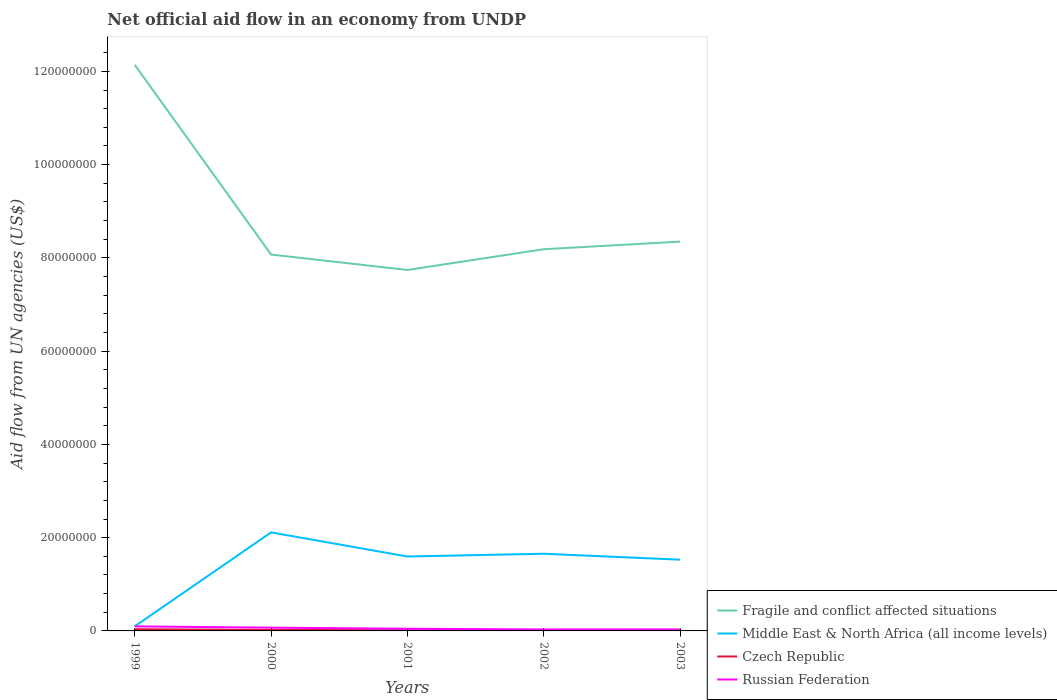How many different coloured lines are there?
Offer a very short reply. 4. Across all years, what is the maximum net official aid flow in Middle East & North Africa (all income levels)?
Your answer should be compact. 9.90e+05. In which year was the net official aid flow in Russian Federation maximum?
Give a very brief answer. 2002. What is the total net official aid flow in Fragile and conflict affected situations in the graph?
Your answer should be compact. 3.79e+07. Is the net official aid flow in Russian Federation strictly greater than the net official aid flow in Fragile and conflict affected situations over the years?
Give a very brief answer. Yes. How many lines are there?
Your response must be concise. 4. What is the difference between two consecutive major ticks on the Y-axis?
Provide a succinct answer. 2.00e+07. Where does the legend appear in the graph?
Offer a very short reply. Bottom right. How many legend labels are there?
Offer a very short reply. 4. How are the legend labels stacked?
Provide a short and direct response. Vertical. What is the title of the graph?
Provide a short and direct response. Net official aid flow in an economy from UNDP. Does "United Kingdom" appear as one of the legend labels in the graph?
Ensure brevity in your answer.  No. What is the label or title of the Y-axis?
Your response must be concise. Aid flow from UN agencies (US$). What is the Aid flow from UN agencies (US$) of Fragile and conflict affected situations in 1999?
Provide a succinct answer. 1.21e+08. What is the Aid flow from UN agencies (US$) of Middle East & North Africa (all income levels) in 1999?
Ensure brevity in your answer.  9.90e+05. What is the Aid flow from UN agencies (US$) in Czech Republic in 1999?
Your response must be concise. 3.70e+05. What is the Aid flow from UN agencies (US$) of Russian Federation in 1999?
Provide a short and direct response. 9.70e+05. What is the Aid flow from UN agencies (US$) in Fragile and conflict affected situations in 2000?
Your answer should be very brief. 8.07e+07. What is the Aid flow from UN agencies (US$) in Middle East & North Africa (all income levels) in 2000?
Provide a short and direct response. 2.11e+07. What is the Aid flow from UN agencies (US$) in Fragile and conflict affected situations in 2001?
Provide a succinct answer. 7.74e+07. What is the Aid flow from UN agencies (US$) of Middle East & North Africa (all income levels) in 2001?
Provide a short and direct response. 1.60e+07. What is the Aid flow from UN agencies (US$) of Czech Republic in 2001?
Offer a very short reply. 1.40e+05. What is the Aid flow from UN agencies (US$) in Fragile and conflict affected situations in 2002?
Keep it short and to the point. 8.19e+07. What is the Aid flow from UN agencies (US$) in Middle East & North Africa (all income levels) in 2002?
Your response must be concise. 1.66e+07. What is the Aid flow from UN agencies (US$) in Czech Republic in 2002?
Ensure brevity in your answer.  8.00e+04. What is the Aid flow from UN agencies (US$) in Fragile and conflict affected situations in 2003?
Your answer should be very brief. 8.35e+07. What is the Aid flow from UN agencies (US$) in Middle East & North Africa (all income levels) in 2003?
Offer a terse response. 1.53e+07. What is the Aid flow from UN agencies (US$) of Russian Federation in 2003?
Give a very brief answer. 3.20e+05. Across all years, what is the maximum Aid flow from UN agencies (US$) of Fragile and conflict affected situations?
Offer a very short reply. 1.21e+08. Across all years, what is the maximum Aid flow from UN agencies (US$) in Middle East & North Africa (all income levels)?
Keep it short and to the point. 2.11e+07. Across all years, what is the maximum Aid flow from UN agencies (US$) in Czech Republic?
Offer a terse response. 3.70e+05. Across all years, what is the maximum Aid flow from UN agencies (US$) of Russian Federation?
Give a very brief answer. 9.70e+05. Across all years, what is the minimum Aid flow from UN agencies (US$) in Fragile and conflict affected situations?
Offer a very short reply. 7.74e+07. Across all years, what is the minimum Aid flow from UN agencies (US$) of Middle East & North Africa (all income levels)?
Offer a terse response. 9.90e+05. Across all years, what is the minimum Aid flow from UN agencies (US$) of Russian Federation?
Offer a terse response. 3.10e+05. What is the total Aid flow from UN agencies (US$) of Fragile and conflict affected situations in the graph?
Your response must be concise. 4.45e+08. What is the total Aid flow from UN agencies (US$) in Middle East & North Africa (all income levels) in the graph?
Your answer should be compact. 6.99e+07. What is the total Aid flow from UN agencies (US$) of Czech Republic in the graph?
Offer a terse response. 9.10e+05. What is the total Aid flow from UN agencies (US$) of Russian Federation in the graph?
Your answer should be very brief. 2.77e+06. What is the difference between the Aid flow from UN agencies (US$) in Fragile and conflict affected situations in 1999 and that in 2000?
Provide a succinct answer. 4.07e+07. What is the difference between the Aid flow from UN agencies (US$) of Middle East & North Africa (all income levels) in 1999 and that in 2000?
Your answer should be very brief. -2.01e+07. What is the difference between the Aid flow from UN agencies (US$) of Fragile and conflict affected situations in 1999 and that in 2001?
Your answer should be very brief. 4.40e+07. What is the difference between the Aid flow from UN agencies (US$) of Middle East & North Africa (all income levels) in 1999 and that in 2001?
Your answer should be compact. -1.50e+07. What is the difference between the Aid flow from UN agencies (US$) in Russian Federation in 1999 and that in 2001?
Your answer should be compact. 5.00e+05. What is the difference between the Aid flow from UN agencies (US$) of Fragile and conflict affected situations in 1999 and that in 2002?
Offer a terse response. 3.95e+07. What is the difference between the Aid flow from UN agencies (US$) of Middle East & North Africa (all income levels) in 1999 and that in 2002?
Give a very brief answer. -1.56e+07. What is the difference between the Aid flow from UN agencies (US$) of Fragile and conflict affected situations in 1999 and that in 2003?
Ensure brevity in your answer.  3.79e+07. What is the difference between the Aid flow from UN agencies (US$) in Middle East & North Africa (all income levels) in 1999 and that in 2003?
Provide a short and direct response. -1.43e+07. What is the difference between the Aid flow from UN agencies (US$) in Czech Republic in 1999 and that in 2003?
Ensure brevity in your answer.  2.70e+05. What is the difference between the Aid flow from UN agencies (US$) in Russian Federation in 1999 and that in 2003?
Your answer should be compact. 6.50e+05. What is the difference between the Aid flow from UN agencies (US$) in Fragile and conflict affected situations in 2000 and that in 2001?
Provide a succinct answer. 3.31e+06. What is the difference between the Aid flow from UN agencies (US$) in Middle East & North Africa (all income levels) in 2000 and that in 2001?
Offer a very short reply. 5.17e+06. What is the difference between the Aid flow from UN agencies (US$) of Russian Federation in 2000 and that in 2001?
Make the answer very short. 2.30e+05. What is the difference between the Aid flow from UN agencies (US$) in Fragile and conflict affected situations in 2000 and that in 2002?
Provide a short and direct response. -1.14e+06. What is the difference between the Aid flow from UN agencies (US$) in Middle East & North Africa (all income levels) in 2000 and that in 2002?
Your answer should be very brief. 4.58e+06. What is the difference between the Aid flow from UN agencies (US$) in Fragile and conflict affected situations in 2000 and that in 2003?
Your answer should be very brief. -2.77e+06. What is the difference between the Aid flow from UN agencies (US$) in Middle East & North Africa (all income levels) in 2000 and that in 2003?
Offer a terse response. 5.85e+06. What is the difference between the Aid flow from UN agencies (US$) of Czech Republic in 2000 and that in 2003?
Your answer should be very brief. 1.20e+05. What is the difference between the Aid flow from UN agencies (US$) in Fragile and conflict affected situations in 2001 and that in 2002?
Offer a terse response. -4.45e+06. What is the difference between the Aid flow from UN agencies (US$) in Middle East & North Africa (all income levels) in 2001 and that in 2002?
Provide a short and direct response. -5.90e+05. What is the difference between the Aid flow from UN agencies (US$) in Czech Republic in 2001 and that in 2002?
Ensure brevity in your answer.  6.00e+04. What is the difference between the Aid flow from UN agencies (US$) in Russian Federation in 2001 and that in 2002?
Offer a terse response. 1.60e+05. What is the difference between the Aid flow from UN agencies (US$) of Fragile and conflict affected situations in 2001 and that in 2003?
Your response must be concise. -6.08e+06. What is the difference between the Aid flow from UN agencies (US$) of Middle East & North Africa (all income levels) in 2001 and that in 2003?
Provide a succinct answer. 6.80e+05. What is the difference between the Aid flow from UN agencies (US$) of Russian Federation in 2001 and that in 2003?
Give a very brief answer. 1.50e+05. What is the difference between the Aid flow from UN agencies (US$) of Fragile and conflict affected situations in 2002 and that in 2003?
Provide a short and direct response. -1.63e+06. What is the difference between the Aid flow from UN agencies (US$) in Middle East & North Africa (all income levels) in 2002 and that in 2003?
Ensure brevity in your answer.  1.27e+06. What is the difference between the Aid flow from UN agencies (US$) in Czech Republic in 2002 and that in 2003?
Your answer should be compact. -2.00e+04. What is the difference between the Aid flow from UN agencies (US$) in Russian Federation in 2002 and that in 2003?
Offer a very short reply. -10000. What is the difference between the Aid flow from UN agencies (US$) of Fragile and conflict affected situations in 1999 and the Aid flow from UN agencies (US$) of Middle East & North Africa (all income levels) in 2000?
Offer a very short reply. 1.00e+08. What is the difference between the Aid flow from UN agencies (US$) of Fragile and conflict affected situations in 1999 and the Aid flow from UN agencies (US$) of Czech Republic in 2000?
Offer a very short reply. 1.21e+08. What is the difference between the Aid flow from UN agencies (US$) in Fragile and conflict affected situations in 1999 and the Aid flow from UN agencies (US$) in Russian Federation in 2000?
Your answer should be very brief. 1.21e+08. What is the difference between the Aid flow from UN agencies (US$) of Middle East & North Africa (all income levels) in 1999 and the Aid flow from UN agencies (US$) of Czech Republic in 2000?
Provide a short and direct response. 7.70e+05. What is the difference between the Aid flow from UN agencies (US$) in Middle East & North Africa (all income levels) in 1999 and the Aid flow from UN agencies (US$) in Russian Federation in 2000?
Provide a succinct answer. 2.90e+05. What is the difference between the Aid flow from UN agencies (US$) of Czech Republic in 1999 and the Aid flow from UN agencies (US$) of Russian Federation in 2000?
Offer a terse response. -3.30e+05. What is the difference between the Aid flow from UN agencies (US$) in Fragile and conflict affected situations in 1999 and the Aid flow from UN agencies (US$) in Middle East & North Africa (all income levels) in 2001?
Give a very brief answer. 1.05e+08. What is the difference between the Aid flow from UN agencies (US$) of Fragile and conflict affected situations in 1999 and the Aid flow from UN agencies (US$) of Czech Republic in 2001?
Make the answer very short. 1.21e+08. What is the difference between the Aid flow from UN agencies (US$) of Fragile and conflict affected situations in 1999 and the Aid flow from UN agencies (US$) of Russian Federation in 2001?
Offer a terse response. 1.21e+08. What is the difference between the Aid flow from UN agencies (US$) in Middle East & North Africa (all income levels) in 1999 and the Aid flow from UN agencies (US$) in Czech Republic in 2001?
Offer a terse response. 8.50e+05. What is the difference between the Aid flow from UN agencies (US$) in Middle East & North Africa (all income levels) in 1999 and the Aid flow from UN agencies (US$) in Russian Federation in 2001?
Provide a succinct answer. 5.20e+05. What is the difference between the Aid flow from UN agencies (US$) of Czech Republic in 1999 and the Aid flow from UN agencies (US$) of Russian Federation in 2001?
Your answer should be compact. -1.00e+05. What is the difference between the Aid flow from UN agencies (US$) of Fragile and conflict affected situations in 1999 and the Aid flow from UN agencies (US$) of Middle East & North Africa (all income levels) in 2002?
Provide a succinct answer. 1.05e+08. What is the difference between the Aid flow from UN agencies (US$) in Fragile and conflict affected situations in 1999 and the Aid flow from UN agencies (US$) in Czech Republic in 2002?
Keep it short and to the point. 1.21e+08. What is the difference between the Aid flow from UN agencies (US$) of Fragile and conflict affected situations in 1999 and the Aid flow from UN agencies (US$) of Russian Federation in 2002?
Your answer should be very brief. 1.21e+08. What is the difference between the Aid flow from UN agencies (US$) in Middle East & North Africa (all income levels) in 1999 and the Aid flow from UN agencies (US$) in Czech Republic in 2002?
Offer a very short reply. 9.10e+05. What is the difference between the Aid flow from UN agencies (US$) in Middle East & North Africa (all income levels) in 1999 and the Aid flow from UN agencies (US$) in Russian Federation in 2002?
Offer a very short reply. 6.80e+05. What is the difference between the Aid flow from UN agencies (US$) in Czech Republic in 1999 and the Aid flow from UN agencies (US$) in Russian Federation in 2002?
Ensure brevity in your answer.  6.00e+04. What is the difference between the Aid flow from UN agencies (US$) in Fragile and conflict affected situations in 1999 and the Aid flow from UN agencies (US$) in Middle East & North Africa (all income levels) in 2003?
Ensure brevity in your answer.  1.06e+08. What is the difference between the Aid flow from UN agencies (US$) of Fragile and conflict affected situations in 1999 and the Aid flow from UN agencies (US$) of Czech Republic in 2003?
Offer a terse response. 1.21e+08. What is the difference between the Aid flow from UN agencies (US$) in Fragile and conflict affected situations in 1999 and the Aid flow from UN agencies (US$) in Russian Federation in 2003?
Make the answer very short. 1.21e+08. What is the difference between the Aid flow from UN agencies (US$) in Middle East & North Africa (all income levels) in 1999 and the Aid flow from UN agencies (US$) in Czech Republic in 2003?
Provide a succinct answer. 8.90e+05. What is the difference between the Aid flow from UN agencies (US$) in Middle East & North Africa (all income levels) in 1999 and the Aid flow from UN agencies (US$) in Russian Federation in 2003?
Your response must be concise. 6.70e+05. What is the difference between the Aid flow from UN agencies (US$) of Czech Republic in 1999 and the Aid flow from UN agencies (US$) of Russian Federation in 2003?
Provide a succinct answer. 5.00e+04. What is the difference between the Aid flow from UN agencies (US$) of Fragile and conflict affected situations in 2000 and the Aid flow from UN agencies (US$) of Middle East & North Africa (all income levels) in 2001?
Keep it short and to the point. 6.48e+07. What is the difference between the Aid flow from UN agencies (US$) of Fragile and conflict affected situations in 2000 and the Aid flow from UN agencies (US$) of Czech Republic in 2001?
Provide a short and direct response. 8.06e+07. What is the difference between the Aid flow from UN agencies (US$) of Fragile and conflict affected situations in 2000 and the Aid flow from UN agencies (US$) of Russian Federation in 2001?
Keep it short and to the point. 8.02e+07. What is the difference between the Aid flow from UN agencies (US$) in Middle East & North Africa (all income levels) in 2000 and the Aid flow from UN agencies (US$) in Czech Republic in 2001?
Provide a succinct answer. 2.10e+07. What is the difference between the Aid flow from UN agencies (US$) of Middle East & North Africa (all income levels) in 2000 and the Aid flow from UN agencies (US$) of Russian Federation in 2001?
Provide a short and direct response. 2.07e+07. What is the difference between the Aid flow from UN agencies (US$) of Czech Republic in 2000 and the Aid flow from UN agencies (US$) of Russian Federation in 2001?
Offer a very short reply. -2.50e+05. What is the difference between the Aid flow from UN agencies (US$) of Fragile and conflict affected situations in 2000 and the Aid flow from UN agencies (US$) of Middle East & North Africa (all income levels) in 2002?
Give a very brief answer. 6.42e+07. What is the difference between the Aid flow from UN agencies (US$) of Fragile and conflict affected situations in 2000 and the Aid flow from UN agencies (US$) of Czech Republic in 2002?
Keep it short and to the point. 8.06e+07. What is the difference between the Aid flow from UN agencies (US$) of Fragile and conflict affected situations in 2000 and the Aid flow from UN agencies (US$) of Russian Federation in 2002?
Your answer should be compact. 8.04e+07. What is the difference between the Aid flow from UN agencies (US$) of Middle East & North Africa (all income levels) in 2000 and the Aid flow from UN agencies (US$) of Czech Republic in 2002?
Your answer should be compact. 2.10e+07. What is the difference between the Aid flow from UN agencies (US$) in Middle East & North Africa (all income levels) in 2000 and the Aid flow from UN agencies (US$) in Russian Federation in 2002?
Your answer should be compact. 2.08e+07. What is the difference between the Aid flow from UN agencies (US$) in Fragile and conflict affected situations in 2000 and the Aid flow from UN agencies (US$) in Middle East & North Africa (all income levels) in 2003?
Your response must be concise. 6.54e+07. What is the difference between the Aid flow from UN agencies (US$) of Fragile and conflict affected situations in 2000 and the Aid flow from UN agencies (US$) of Czech Republic in 2003?
Give a very brief answer. 8.06e+07. What is the difference between the Aid flow from UN agencies (US$) in Fragile and conflict affected situations in 2000 and the Aid flow from UN agencies (US$) in Russian Federation in 2003?
Your answer should be compact. 8.04e+07. What is the difference between the Aid flow from UN agencies (US$) of Middle East & North Africa (all income levels) in 2000 and the Aid flow from UN agencies (US$) of Czech Republic in 2003?
Offer a terse response. 2.10e+07. What is the difference between the Aid flow from UN agencies (US$) in Middle East & North Africa (all income levels) in 2000 and the Aid flow from UN agencies (US$) in Russian Federation in 2003?
Ensure brevity in your answer.  2.08e+07. What is the difference between the Aid flow from UN agencies (US$) in Fragile and conflict affected situations in 2001 and the Aid flow from UN agencies (US$) in Middle East & North Africa (all income levels) in 2002?
Your answer should be very brief. 6.09e+07. What is the difference between the Aid flow from UN agencies (US$) of Fragile and conflict affected situations in 2001 and the Aid flow from UN agencies (US$) of Czech Republic in 2002?
Provide a short and direct response. 7.73e+07. What is the difference between the Aid flow from UN agencies (US$) in Fragile and conflict affected situations in 2001 and the Aid flow from UN agencies (US$) in Russian Federation in 2002?
Give a very brief answer. 7.71e+07. What is the difference between the Aid flow from UN agencies (US$) of Middle East & North Africa (all income levels) in 2001 and the Aid flow from UN agencies (US$) of Czech Republic in 2002?
Offer a terse response. 1.59e+07. What is the difference between the Aid flow from UN agencies (US$) in Middle East & North Africa (all income levels) in 2001 and the Aid flow from UN agencies (US$) in Russian Federation in 2002?
Your response must be concise. 1.56e+07. What is the difference between the Aid flow from UN agencies (US$) in Czech Republic in 2001 and the Aid flow from UN agencies (US$) in Russian Federation in 2002?
Your answer should be compact. -1.70e+05. What is the difference between the Aid flow from UN agencies (US$) of Fragile and conflict affected situations in 2001 and the Aid flow from UN agencies (US$) of Middle East & North Africa (all income levels) in 2003?
Provide a short and direct response. 6.21e+07. What is the difference between the Aid flow from UN agencies (US$) in Fragile and conflict affected situations in 2001 and the Aid flow from UN agencies (US$) in Czech Republic in 2003?
Offer a very short reply. 7.73e+07. What is the difference between the Aid flow from UN agencies (US$) in Fragile and conflict affected situations in 2001 and the Aid flow from UN agencies (US$) in Russian Federation in 2003?
Your answer should be compact. 7.71e+07. What is the difference between the Aid flow from UN agencies (US$) in Middle East & North Africa (all income levels) in 2001 and the Aid flow from UN agencies (US$) in Czech Republic in 2003?
Your answer should be very brief. 1.59e+07. What is the difference between the Aid flow from UN agencies (US$) of Middle East & North Africa (all income levels) in 2001 and the Aid flow from UN agencies (US$) of Russian Federation in 2003?
Provide a succinct answer. 1.56e+07. What is the difference between the Aid flow from UN agencies (US$) of Fragile and conflict affected situations in 2002 and the Aid flow from UN agencies (US$) of Middle East & North Africa (all income levels) in 2003?
Keep it short and to the point. 6.66e+07. What is the difference between the Aid flow from UN agencies (US$) of Fragile and conflict affected situations in 2002 and the Aid flow from UN agencies (US$) of Czech Republic in 2003?
Your answer should be very brief. 8.18e+07. What is the difference between the Aid flow from UN agencies (US$) of Fragile and conflict affected situations in 2002 and the Aid flow from UN agencies (US$) of Russian Federation in 2003?
Your response must be concise. 8.15e+07. What is the difference between the Aid flow from UN agencies (US$) in Middle East & North Africa (all income levels) in 2002 and the Aid flow from UN agencies (US$) in Czech Republic in 2003?
Your answer should be very brief. 1.64e+07. What is the difference between the Aid flow from UN agencies (US$) of Middle East & North Africa (all income levels) in 2002 and the Aid flow from UN agencies (US$) of Russian Federation in 2003?
Provide a short and direct response. 1.62e+07. What is the average Aid flow from UN agencies (US$) of Fragile and conflict affected situations per year?
Your answer should be compact. 8.90e+07. What is the average Aid flow from UN agencies (US$) of Middle East & North Africa (all income levels) per year?
Your response must be concise. 1.40e+07. What is the average Aid flow from UN agencies (US$) in Czech Republic per year?
Offer a very short reply. 1.82e+05. What is the average Aid flow from UN agencies (US$) of Russian Federation per year?
Offer a very short reply. 5.54e+05. In the year 1999, what is the difference between the Aid flow from UN agencies (US$) in Fragile and conflict affected situations and Aid flow from UN agencies (US$) in Middle East & North Africa (all income levels)?
Make the answer very short. 1.20e+08. In the year 1999, what is the difference between the Aid flow from UN agencies (US$) in Fragile and conflict affected situations and Aid flow from UN agencies (US$) in Czech Republic?
Your response must be concise. 1.21e+08. In the year 1999, what is the difference between the Aid flow from UN agencies (US$) in Fragile and conflict affected situations and Aid flow from UN agencies (US$) in Russian Federation?
Make the answer very short. 1.20e+08. In the year 1999, what is the difference between the Aid flow from UN agencies (US$) of Middle East & North Africa (all income levels) and Aid flow from UN agencies (US$) of Czech Republic?
Ensure brevity in your answer.  6.20e+05. In the year 1999, what is the difference between the Aid flow from UN agencies (US$) in Middle East & North Africa (all income levels) and Aid flow from UN agencies (US$) in Russian Federation?
Give a very brief answer. 2.00e+04. In the year 1999, what is the difference between the Aid flow from UN agencies (US$) in Czech Republic and Aid flow from UN agencies (US$) in Russian Federation?
Ensure brevity in your answer.  -6.00e+05. In the year 2000, what is the difference between the Aid flow from UN agencies (US$) of Fragile and conflict affected situations and Aid flow from UN agencies (US$) of Middle East & North Africa (all income levels)?
Ensure brevity in your answer.  5.96e+07. In the year 2000, what is the difference between the Aid flow from UN agencies (US$) in Fragile and conflict affected situations and Aid flow from UN agencies (US$) in Czech Republic?
Give a very brief answer. 8.05e+07. In the year 2000, what is the difference between the Aid flow from UN agencies (US$) of Fragile and conflict affected situations and Aid flow from UN agencies (US$) of Russian Federation?
Give a very brief answer. 8.00e+07. In the year 2000, what is the difference between the Aid flow from UN agencies (US$) of Middle East & North Africa (all income levels) and Aid flow from UN agencies (US$) of Czech Republic?
Provide a succinct answer. 2.09e+07. In the year 2000, what is the difference between the Aid flow from UN agencies (US$) of Middle East & North Africa (all income levels) and Aid flow from UN agencies (US$) of Russian Federation?
Keep it short and to the point. 2.04e+07. In the year 2000, what is the difference between the Aid flow from UN agencies (US$) in Czech Republic and Aid flow from UN agencies (US$) in Russian Federation?
Make the answer very short. -4.80e+05. In the year 2001, what is the difference between the Aid flow from UN agencies (US$) in Fragile and conflict affected situations and Aid flow from UN agencies (US$) in Middle East & North Africa (all income levels)?
Give a very brief answer. 6.14e+07. In the year 2001, what is the difference between the Aid flow from UN agencies (US$) of Fragile and conflict affected situations and Aid flow from UN agencies (US$) of Czech Republic?
Give a very brief answer. 7.73e+07. In the year 2001, what is the difference between the Aid flow from UN agencies (US$) in Fragile and conflict affected situations and Aid flow from UN agencies (US$) in Russian Federation?
Give a very brief answer. 7.69e+07. In the year 2001, what is the difference between the Aid flow from UN agencies (US$) in Middle East & North Africa (all income levels) and Aid flow from UN agencies (US$) in Czech Republic?
Your answer should be compact. 1.58e+07. In the year 2001, what is the difference between the Aid flow from UN agencies (US$) in Middle East & North Africa (all income levels) and Aid flow from UN agencies (US$) in Russian Federation?
Your answer should be compact. 1.55e+07. In the year 2001, what is the difference between the Aid flow from UN agencies (US$) of Czech Republic and Aid flow from UN agencies (US$) of Russian Federation?
Offer a terse response. -3.30e+05. In the year 2002, what is the difference between the Aid flow from UN agencies (US$) of Fragile and conflict affected situations and Aid flow from UN agencies (US$) of Middle East & North Africa (all income levels)?
Ensure brevity in your answer.  6.53e+07. In the year 2002, what is the difference between the Aid flow from UN agencies (US$) of Fragile and conflict affected situations and Aid flow from UN agencies (US$) of Czech Republic?
Provide a short and direct response. 8.18e+07. In the year 2002, what is the difference between the Aid flow from UN agencies (US$) of Fragile and conflict affected situations and Aid flow from UN agencies (US$) of Russian Federation?
Offer a very short reply. 8.16e+07. In the year 2002, what is the difference between the Aid flow from UN agencies (US$) of Middle East & North Africa (all income levels) and Aid flow from UN agencies (US$) of Czech Republic?
Your response must be concise. 1.65e+07. In the year 2002, what is the difference between the Aid flow from UN agencies (US$) of Middle East & North Africa (all income levels) and Aid flow from UN agencies (US$) of Russian Federation?
Provide a succinct answer. 1.62e+07. In the year 2003, what is the difference between the Aid flow from UN agencies (US$) in Fragile and conflict affected situations and Aid flow from UN agencies (US$) in Middle East & North Africa (all income levels)?
Your response must be concise. 6.82e+07. In the year 2003, what is the difference between the Aid flow from UN agencies (US$) of Fragile and conflict affected situations and Aid flow from UN agencies (US$) of Czech Republic?
Offer a very short reply. 8.34e+07. In the year 2003, what is the difference between the Aid flow from UN agencies (US$) in Fragile and conflict affected situations and Aid flow from UN agencies (US$) in Russian Federation?
Your answer should be very brief. 8.32e+07. In the year 2003, what is the difference between the Aid flow from UN agencies (US$) of Middle East & North Africa (all income levels) and Aid flow from UN agencies (US$) of Czech Republic?
Offer a very short reply. 1.52e+07. In the year 2003, what is the difference between the Aid flow from UN agencies (US$) in Middle East & North Africa (all income levels) and Aid flow from UN agencies (US$) in Russian Federation?
Keep it short and to the point. 1.50e+07. In the year 2003, what is the difference between the Aid flow from UN agencies (US$) in Czech Republic and Aid flow from UN agencies (US$) in Russian Federation?
Provide a succinct answer. -2.20e+05. What is the ratio of the Aid flow from UN agencies (US$) in Fragile and conflict affected situations in 1999 to that in 2000?
Give a very brief answer. 1.5. What is the ratio of the Aid flow from UN agencies (US$) of Middle East & North Africa (all income levels) in 1999 to that in 2000?
Your answer should be compact. 0.05. What is the ratio of the Aid flow from UN agencies (US$) of Czech Republic in 1999 to that in 2000?
Ensure brevity in your answer.  1.68. What is the ratio of the Aid flow from UN agencies (US$) in Russian Federation in 1999 to that in 2000?
Keep it short and to the point. 1.39. What is the ratio of the Aid flow from UN agencies (US$) in Fragile and conflict affected situations in 1999 to that in 2001?
Give a very brief answer. 1.57. What is the ratio of the Aid flow from UN agencies (US$) in Middle East & North Africa (all income levels) in 1999 to that in 2001?
Your answer should be compact. 0.06. What is the ratio of the Aid flow from UN agencies (US$) of Czech Republic in 1999 to that in 2001?
Your answer should be compact. 2.64. What is the ratio of the Aid flow from UN agencies (US$) in Russian Federation in 1999 to that in 2001?
Provide a succinct answer. 2.06. What is the ratio of the Aid flow from UN agencies (US$) of Fragile and conflict affected situations in 1999 to that in 2002?
Offer a terse response. 1.48. What is the ratio of the Aid flow from UN agencies (US$) of Middle East & North Africa (all income levels) in 1999 to that in 2002?
Ensure brevity in your answer.  0.06. What is the ratio of the Aid flow from UN agencies (US$) in Czech Republic in 1999 to that in 2002?
Provide a short and direct response. 4.62. What is the ratio of the Aid flow from UN agencies (US$) of Russian Federation in 1999 to that in 2002?
Make the answer very short. 3.13. What is the ratio of the Aid flow from UN agencies (US$) of Fragile and conflict affected situations in 1999 to that in 2003?
Provide a succinct answer. 1.45. What is the ratio of the Aid flow from UN agencies (US$) in Middle East & North Africa (all income levels) in 1999 to that in 2003?
Keep it short and to the point. 0.06. What is the ratio of the Aid flow from UN agencies (US$) of Czech Republic in 1999 to that in 2003?
Keep it short and to the point. 3.7. What is the ratio of the Aid flow from UN agencies (US$) in Russian Federation in 1999 to that in 2003?
Ensure brevity in your answer.  3.03. What is the ratio of the Aid flow from UN agencies (US$) in Fragile and conflict affected situations in 2000 to that in 2001?
Keep it short and to the point. 1.04. What is the ratio of the Aid flow from UN agencies (US$) in Middle East & North Africa (all income levels) in 2000 to that in 2001?
Offer a very short reply. 1.32. What is the ratio of the Aid flow from UN agencies (US$) in Czech Republic in 2000 to that in 2001?
Ensure brevity in your answer.  1.57. What is the ratio of the Aid flow from UN agencies (US$) in Russian Federation in 2000 to that in 2001?
Give a very brief answer. 1.49. What is the ratio of the Aid flow from UN agencies (US$) in Fragile and conflict affected situations in 2000 to that in 2002?
Your answer should be very brief. 0.99. What is the ratio of the Aid flow from UN agencies (US$) in Middle East & North Africa (all income levels) in 2000 to that in 2002?
Offer a terse response. 1.28. What is the ratio of the Aid flow from UN agencies (US$) of Czech Republic in 2000 to that in 2002?
Your response must be concise. 2.75. What is the ratio of the Aid flow from UN agencies (US$) of Russian Federation in 2000 to that in 2002?
Ensure brevity in your answer.  2.26. What is the ratio of the Aid flow from UN agencies (US$) in Fragile and conflict affected situations in 2000 to that in 2003?
Provide a succinct answer. 0.97. What is the ratio of the Aid flow from UN agencies (US$) of Middle East & North Africa (all income levels) in 2000 to that in 2003?
Make the answer very short. 1.38. What is the ratio of the Aid flow from UN agencies (US$) of Russian Federation in 2000 to that in 2003?
Provide a succinct answer. 2.19. What is the ratio of the Aid flow from UN agencies (US$) of Fragile and conflict affected situations in 2001 to that in 2002?
Your answer should be compact. 0.95. What is the ratio of the Aid flow from UN agencies (US$) in Middle East & North Africa (all income levels) in 2001 to that in 2002?
Your response must be concise. 0.96. What is the ratio of the Aid flow from UN agencies (US$) in Russian Federation in 2001 to that in 2002?
Your answer should be compact. 1.52. What is the ratio of the Aid flow from UN agencies (US$) of Fragile and conflict affected situations in 2001 to that in 2003?
Your response must be concise. 0.93. What is the ratio of the Aid flow from UN agencies (US$) in Middle East & North Africa (all income levels) in 2001 to that in 2003?
Your response must be concise. 1.04. What is the ratio of the Aid flow from UN agencies (US$) in Czech Republic in 2001 to that in 2003?
Give a very brief answer. 1.4. What is the ratio of the Aid flow from UN agencies (US$) in Russian Federation in 2001 to that in 2003?
Keep it short and to the point. 1.47. What is the ratio of the Aid flow from UN agencies (US$) of Fragile and conflict affected situations in 2002 to that in 2003?
Provide a short and direct response. 0.98. What is the ratio of the Aid flow from UN agencies (US$) in Middle East & North Africa (all income levels) in 2002 to that in 2003?
Provide a short and direct response. 1.08. What is the ratio of the Aid flow from UN agencies (US$) in Czech Republic in 2002 to that in 2003?
Your answer should be compact. 0.8. What is the ratio of the Aid flow from UN agencies (US$) of Russian Federation in 2002 to that in 2003?
Provide a succinct answer. 0.97. What is the difference between the highest and the second highest Aid flow from UN agencies (US$) of Fragile and conflict affected situations?
Provide a short and direct response. 3.79e+07. What is the difference between the highest and the second highest Aid flow from UN agencies (US$) of Middle East & North Africa (all income levels)?
Offer a terse response. 4.58e+06. What is the difference between the highest and the second highest Aid flow from UN agencies (US$) in Czech Republic?
Your answer should be compact. 1.50e+05. What is the difference between the highest and the second highest Aid flow from UN agencies (US$) in Russian Federation?
Your answer should be very brief. 2.70e+05. What is the difference between the highest and the lowest Aid flow from UN agencies (US$) in Fragile and conflict affected situations?
Your answer should be very brief. 4.40e+07. What is the difference between the highest and the lowest Aid flow from UN agencies (US$) in Middle East & North Africa (all income levels)?
Keep it short and to the point. 2.01e+07. What is the difference between the highest and the lowest Aid flow from UN agencies (US$) in Russian Federation?
Make the answer very short. 6.60e+05. 